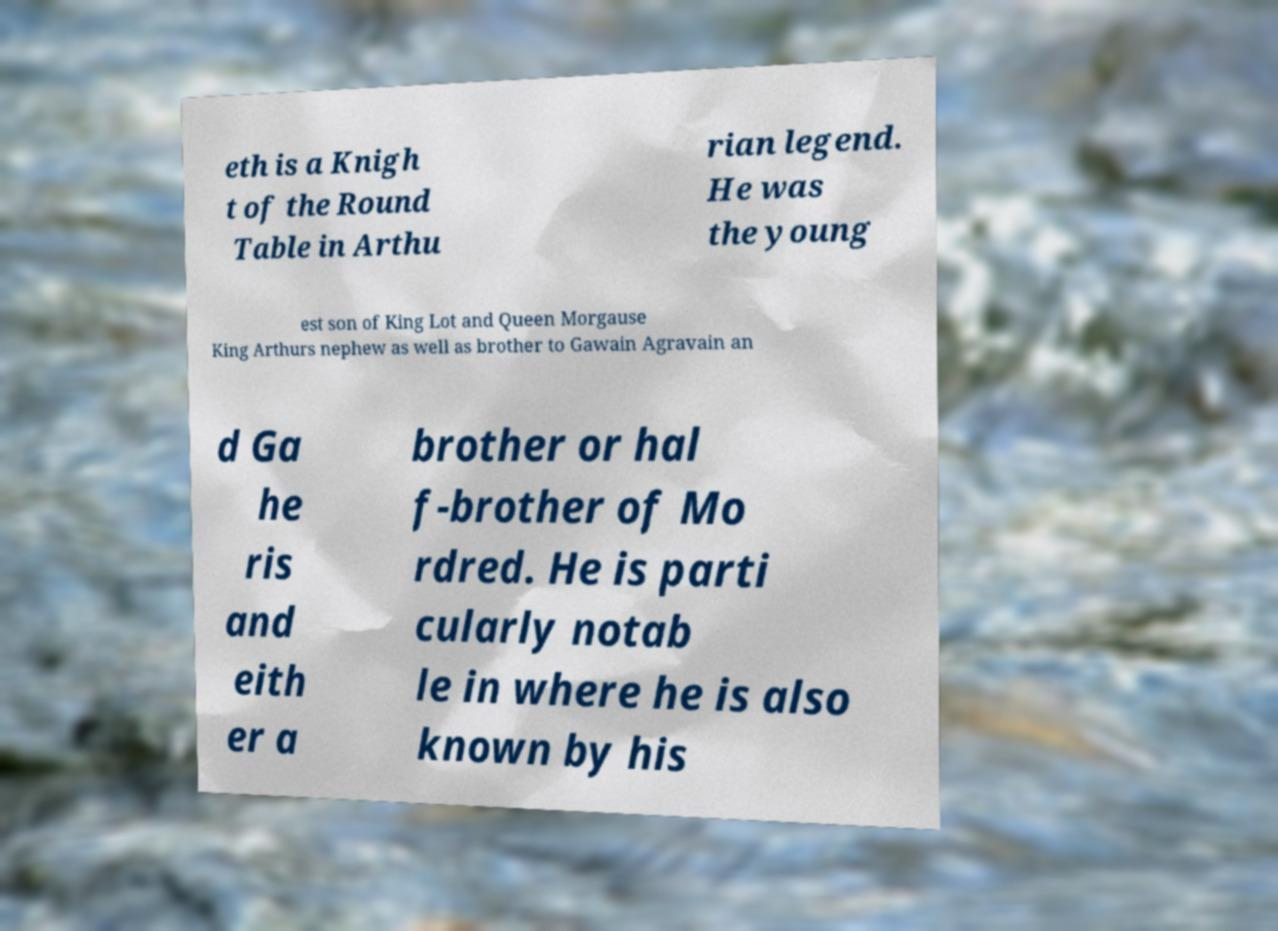Could you extract and type out the text from this image? eth is a Knigh t of the Round Table in Arthu rian legend. He was the young est son of King Lot and Queen Morgause King Arthurs nephew as well as brother to Gawain Agravain an d Ga he ris and eith er a brother or hal f-brother of Mo rdred. He is parti cularly notab le in where he is also known by his 